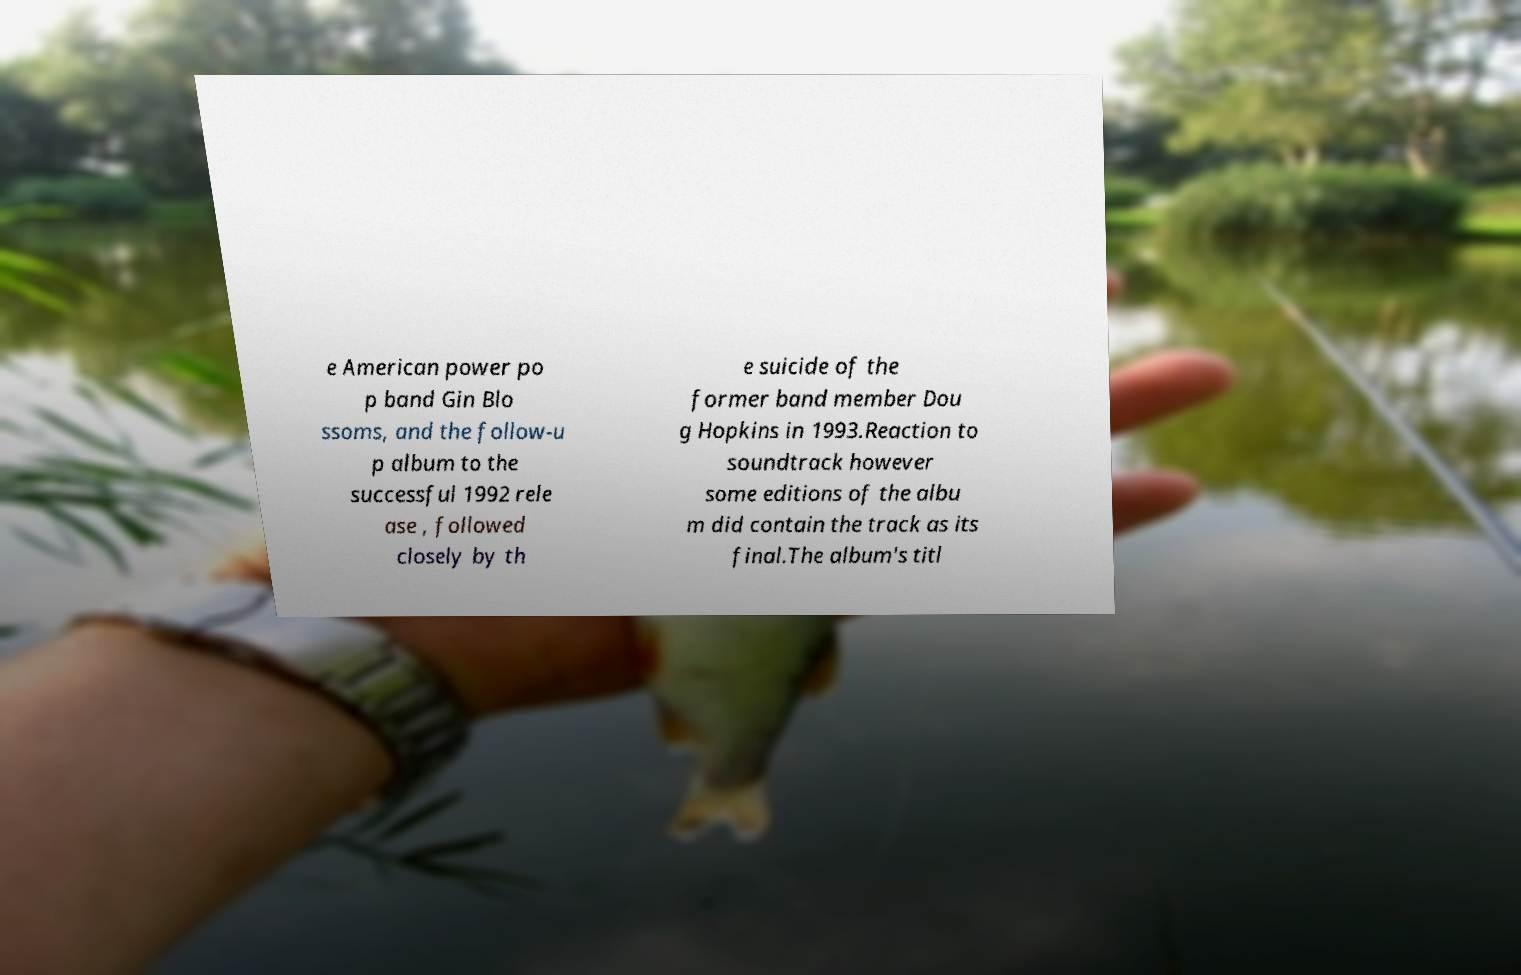Could you extract and type out the text from this image? e American power po p band Gin Blo ssoms, and the follow-u p album to the successful 1992 rele ase , followed closely by th e suicide of the former band member Dou g Hopkins in 1993.Reaction to soundtrack however some editions of the albu m did contain the track as its final.The album's titl 